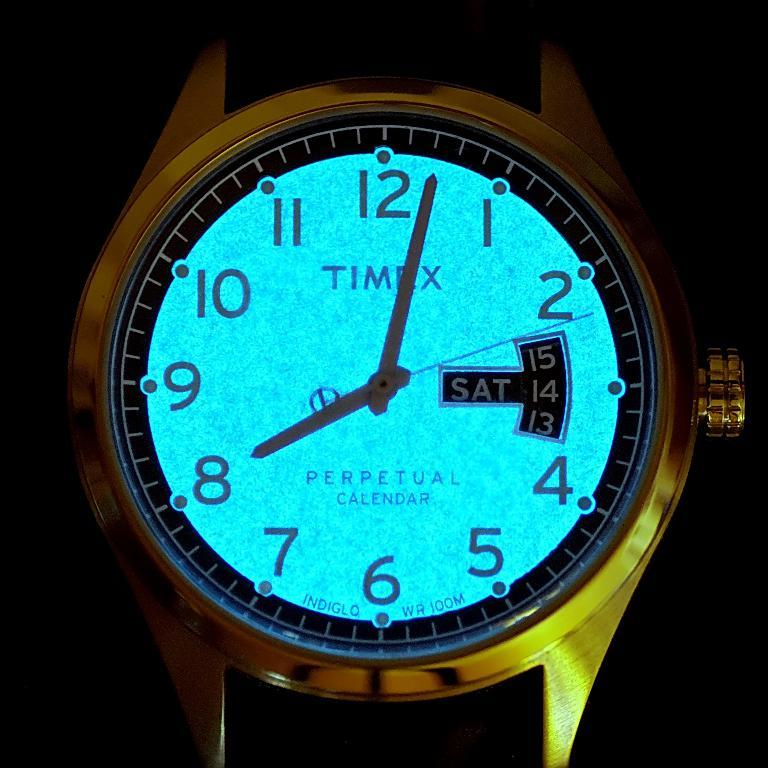<image>
Relay a brief, clear account of the picture shown. Glowing watch that has the word TIMEX on the face. 